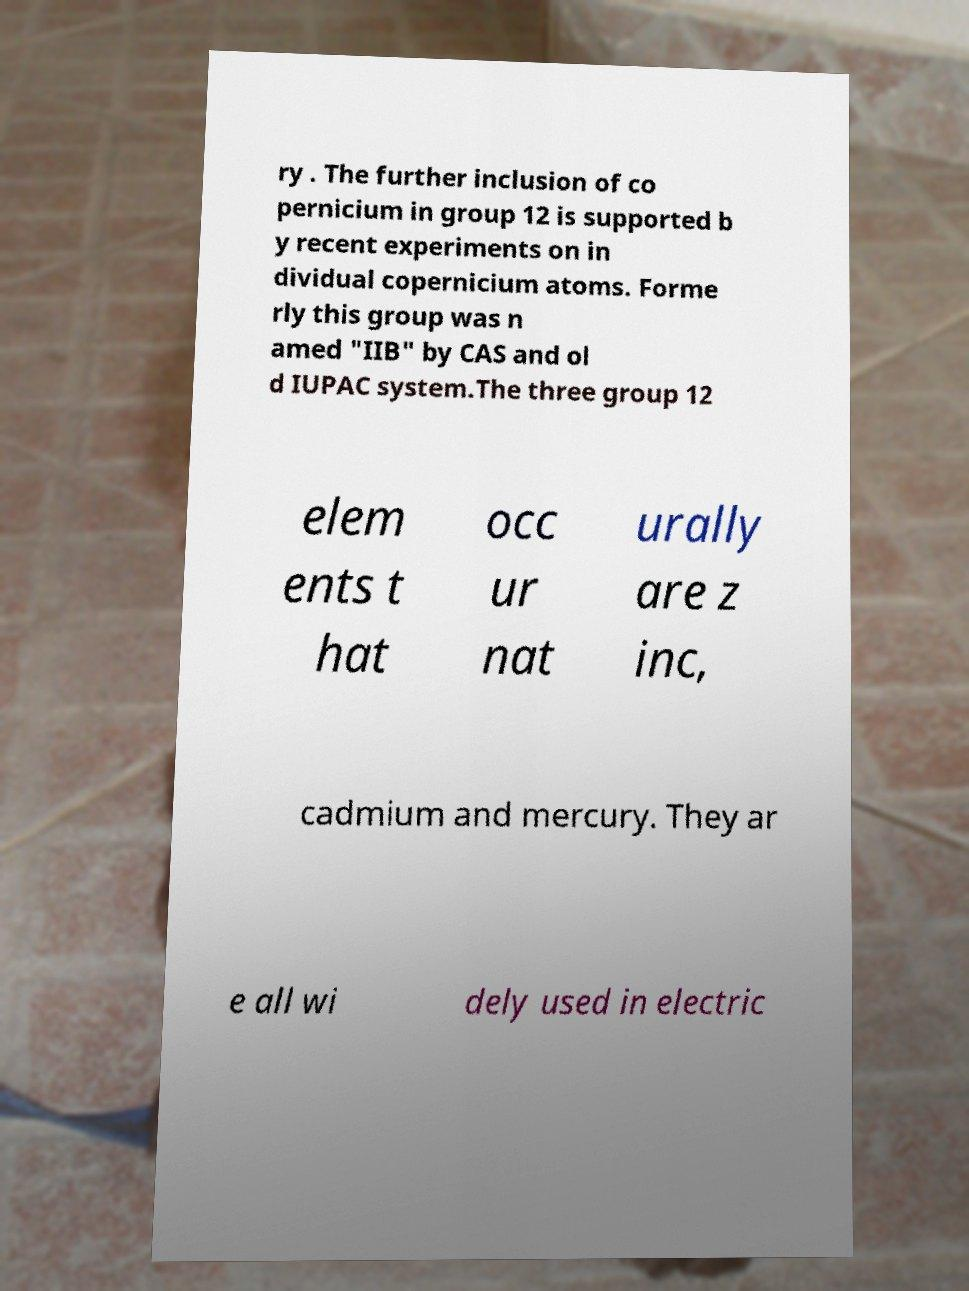What messages or text are displayed in this image? I need them in a readable, typed format. ry . The further inclusion of co pernicium in group 12 is supported b y recent experiments on in dividual copernicium atoms. Forme rly this group was n amed "IIB" by CAS and ol d IUPAC system.The three group 12 elem ents t hat occ ur nat urally are z inc, cadmium and mercury. They ar e all wi dely used in electric 